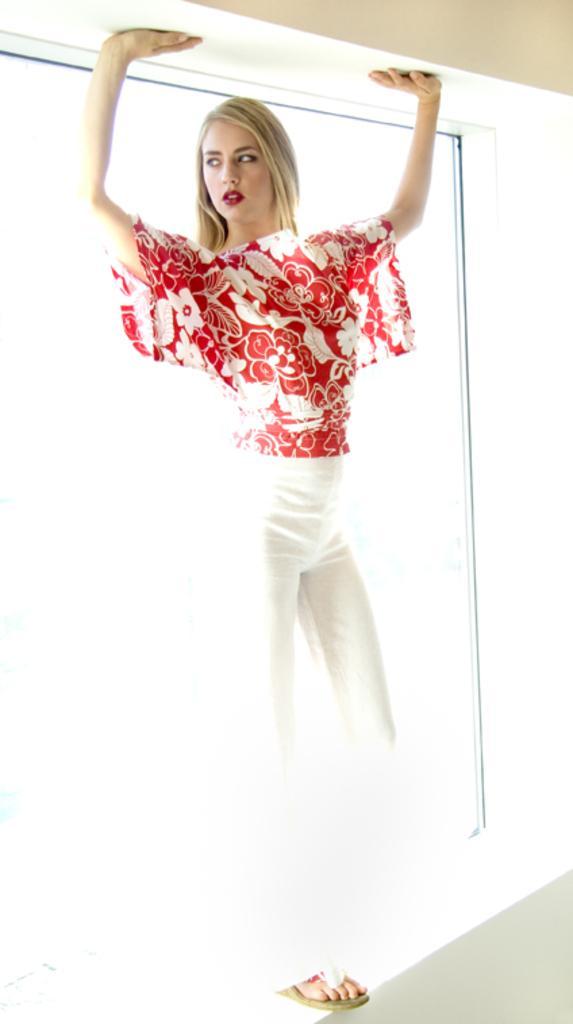How would you summarize this image in a sentence or two? This image consists of a woman wearing red top and white pant is standing on the wall. In the background, there is a window. At the top, there is beam. 